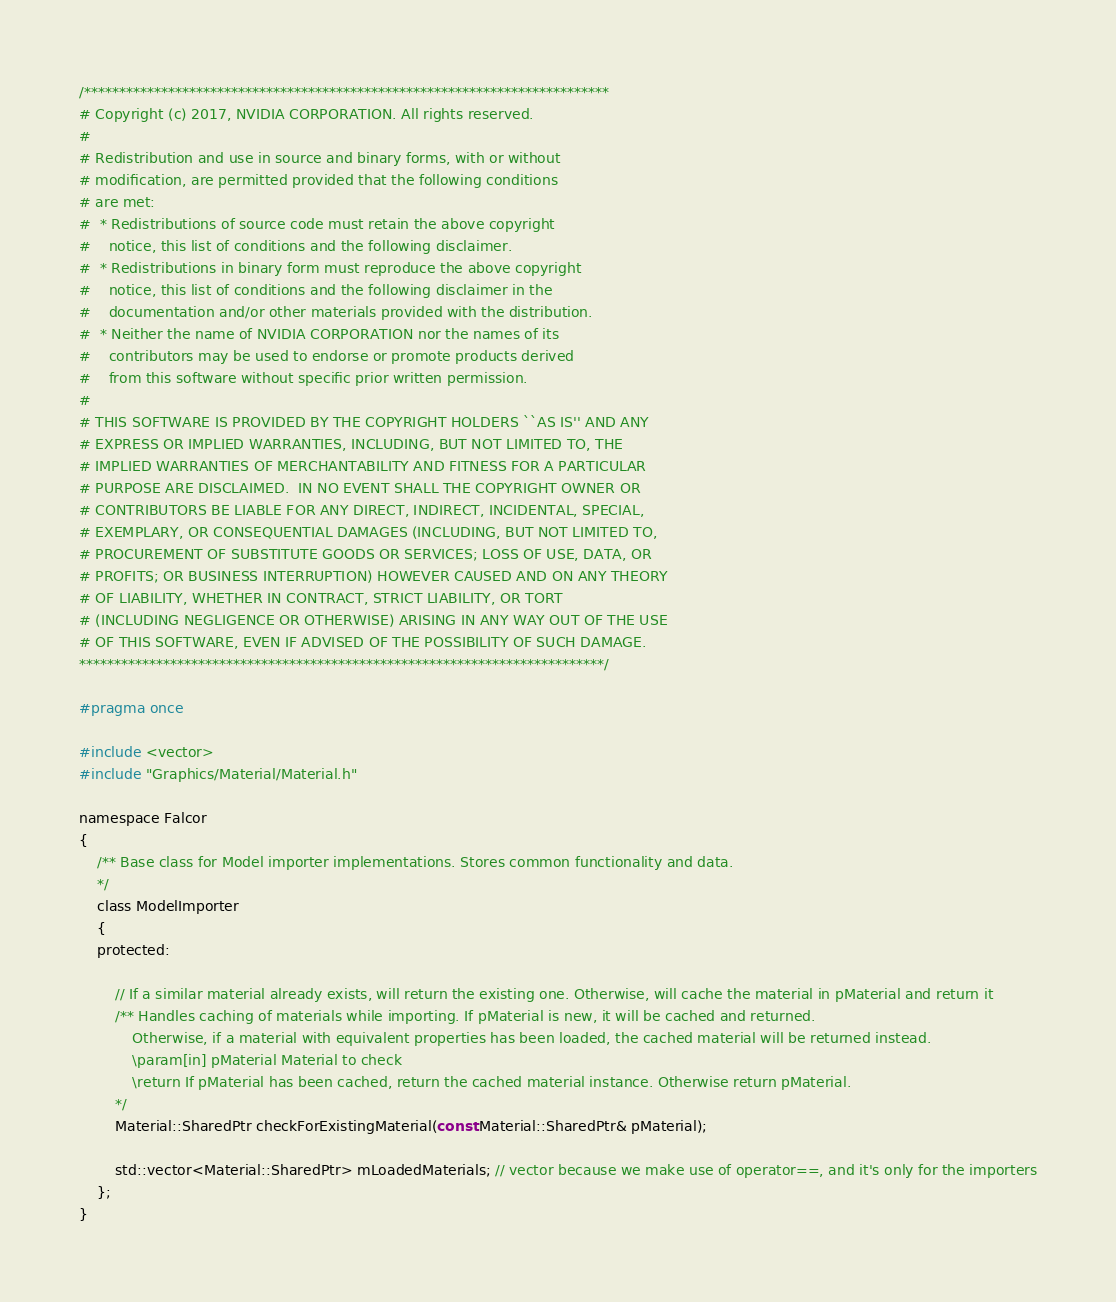<code> <loc_0><loc_0><loc_500><loc_500><_C_>/***************************************************************************
# Copyright (c) 2017, NVIDIA CORPORATION. All rights reserved.
#
# Redistribution and use in source and binary forms, with or without
# modification, are permitted provided that the following conditions
# are met:
#  * Redistributions of source code must retain the above copyright
#    notice, this list of conditions and the following disclaimer.
#  * Redistributions in binary form must reproduce the above copyright
#    notice, this list of conditions and the following disclaimer in the
#    documentation and/or other materials provided with the distribution.
#  * Neither the name of NVIDIA CORPORATION nor the names of its
#    contributors may be used to endorse or promote products derived
#    from this software without specific prior written permission.
#
# THIS SOFTWARE IS PROVIDED BY THE COPYRIGHT HOLDERS ``AS IS'' AND ANY
# EXPRESS OR IMPLIED WARRANTIES, INCLUDING, BUT NOT LIMITED TO, THE
# IMPLIED WARRANTIES OF MERCHANTABILITY AND FITNESS FOR A PARTICULAR
# PURPOSE ARE DISCLAIMED.  IN NO EVENT SHALL THE COPYRIGHT OWNER OR
# CONTRIBUTORS BE LIABLE FOR ANY DIRECT, INDIRECT, INCIDENTAL, SPECIAL,
# EXEMPLARY, OR CONSEQUENTIAL DAMAGES (INCLUDING, BUT NOT LIMITED TO,
# PROCUREMENT OF SUBSTITUTE GOODS OR SERVICES; LOSS OF USE, DATA, OR
# PROFITS; OR BUSINESS INTERRUPTION) HOWEVER CAUSED AND ON ANY THEORY
# OF LIABILITY, WHETHER IN CONTRACT, STRICT LIABILITY, OR TORT
# (INCLUDING NEGLIGENCE OR OTHERWISE) ARISING IN ANY WAY OUT OF THE USE
# OF THIS SOFTWARE, EVEN IF ADVISED OF THE POSSIBILITY OF SUCH DAMAGE.
***************************************************************************/

#pragma once

#include <vector>
#include "Graphics/Material/Material.h"

namespace Falcor
{
    /** Base class for Model importer implementations. Stores common functionality and data.
    */
    class ModelImporter
    {
    protected:

        // If a similar material already exists, will return the existing one. Otherwise, will cache the material in pMaterial and return it
        /** Handles caching of materials while importing. If pMaterial is new, it will be cached and returned. 
            Otherwise, if a material with equivalent properties has been loaded, the cached material will be returned instead.
            \param[in] pMaterial Material to check
            \return If pMaterial has been cached, return the cached material instance. Otherwise return pMaterial.
        */
        Material::SharedPtr checkForExistingMaterial(const Material::SharedPtr& pMaterial);

        std::vector<Material::SharedPtr> mLoadedMaterials; // vector because we make use of operator==, and it's only for the importers
    };
}
</code> 